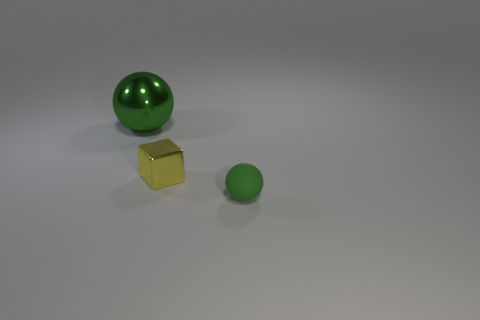Add 3 tiny green rubber balls. How many objects exist? 6 Subtract all blocks. How many objects are left? 2 Add 1 green metal spheres. How many green metal spheres exist? 2 Subtract 0 green cylinders. How many objects are left? 3 Subtract all large metal objects. Subtract all small green objects. How many objects are left? 1 Add 1 cubes. How many cubes are left? 2 